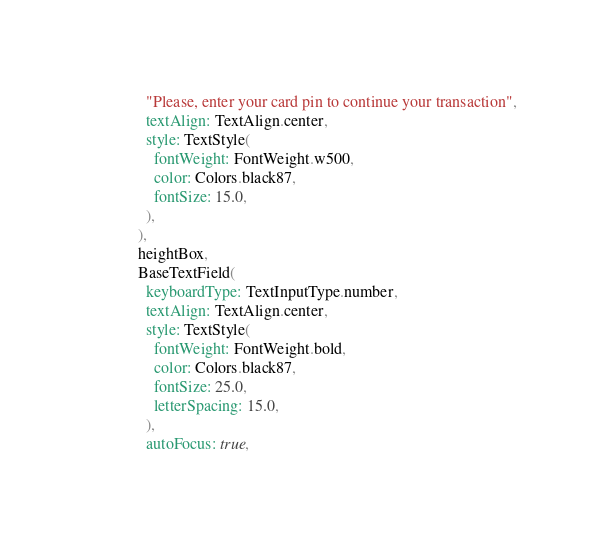<code> <loc_0><loc_0><loc_500><loc_500><_Dart_>              "Please, enter your card pin to continue your transaction",
              textAlign: TextAlign.center,
              style: TextStyle(
                fontWeight: FontWeight.w500,
                color: Colors.black87,
                fontSize: 15.0,
              ),
            ),
            heightBox,
            BaseTextField(
              keyboardType: TextInputType.number,
              textAlign: TextAlign.center,
              style: TextStyle(
                fontWeight: FontWeight.bold,
                color: Colors.black87,
                fontSize: 25.0,
                letterSpacing: 15.0,
              ),
              autoFocus: true,</code> 